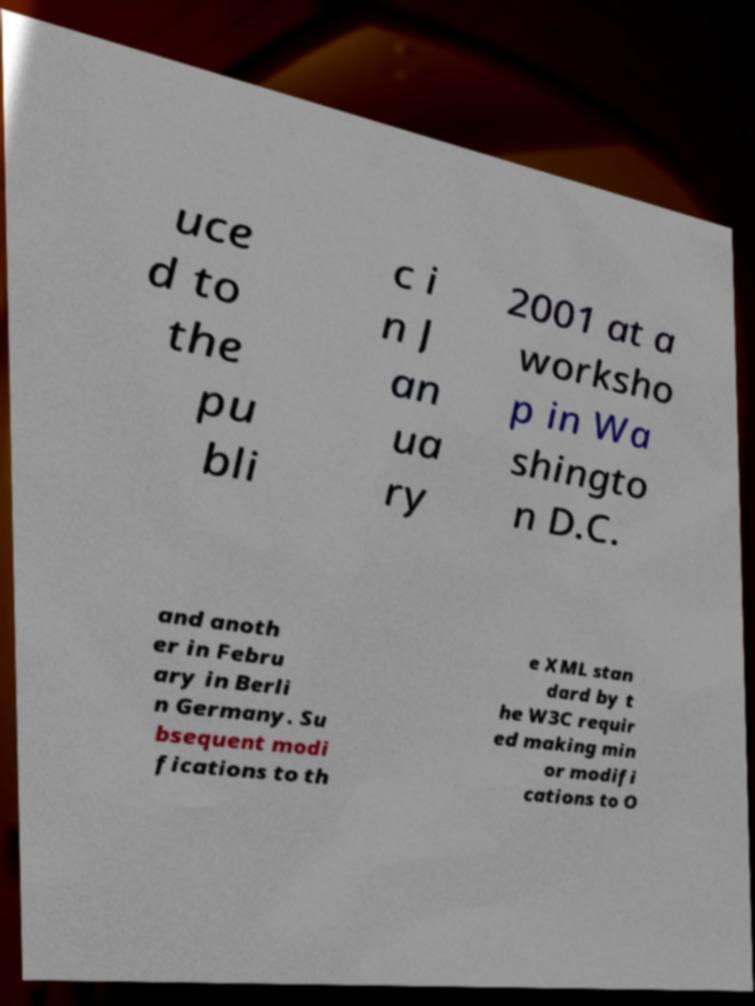There's text embedded in this image that I need extracted. Can you transcribe it verbatim? uce d to the pu bli c i n J an ua ry 2001 at a worksho p in Wa shingto n D.C. and anoth er in Febru ary in Berli n Germany. Su bsequent modi fications to th e XML stan dard by t he W3C requir ed making min or modifi cations to O 